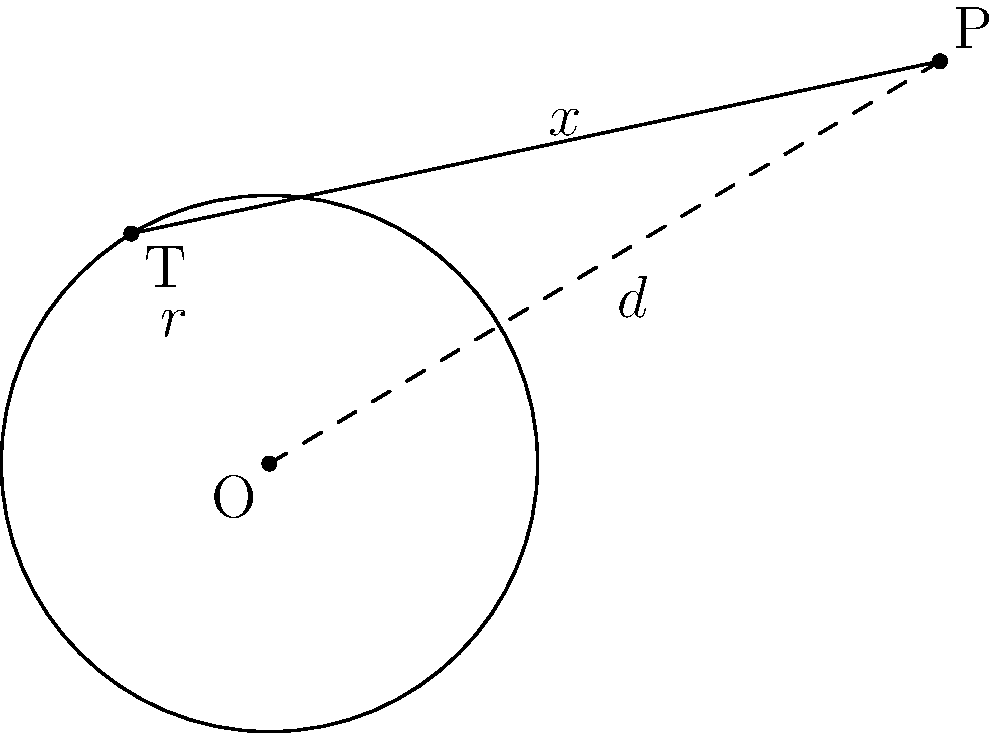In the diagram, O is the center of a circle with radius $r = 2$ units. Point P is external to the circle, and the distance from O to P is $d = \sqrt{34}$ units. A tangent line is drawn from P to the circle, touching the circle at point T. Calculate the length of the tangent line PT (denoted as $x$ in the diagram). Express your answer in simplified radical form. To solve this problem, we'll use the Pythagorean theorem and the properties of tangent lines to circles. Let's proceed step-by-step:

1) In right triangle OTP:
   - OT is a radius of the circle, so OT = $r = 2$
   - PT is the tangent line we're trying to find (let's call its length $x$)
   - OP is the distance from the center to the external point, given as $d = \sqrt{34}$

2) The tangent line is perpendicular to the radius at the point of tangency. This means that triangle OTP is a right triangle.

3) We can apply the Pythagorean theorem to this triangle:
   $OP^2 = OT^2 + PT^2$

4) Substituting the known values:
   $(\sqrt{34})^2 = 2^2 + x^2$

5) Simplify:
   $34 = 4 + x^2$

6) Subtract 4 from both sides:
   $30 = x^2$

7) Take the square root of both sides:
   $x = \sqrt{30}$

8) Simplify $\sqrt{30}$:
   $x = \sqrt{2 \cdot 15} = \sqrt{2} \cdot \sqrt{15}$

Therefore, the length of the tangent line PT is $\sqrt{30} = \sqrt{2} \cdot \sqrt{15}$ units.
Answer: $\sqrt{2} \cdot \sqrt{15}$ units 